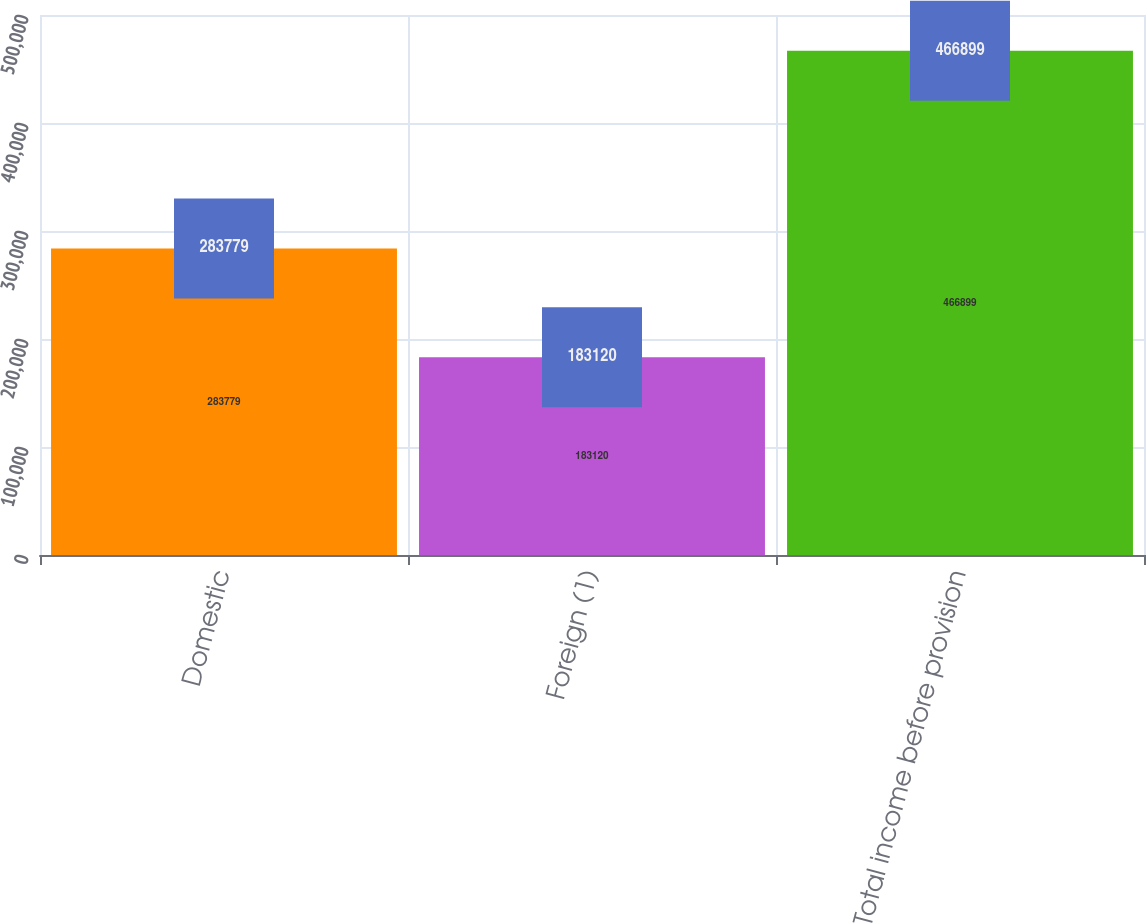Convert chart. <chart><loc_0><loc_0><loc_500><loc_500><bar_chart><fcel>Domestic<fcel>Foreign (1)<fcel>Total income before provision<nl><fcel>283779<fcel>183120<fcel>466899<nl></chart> 